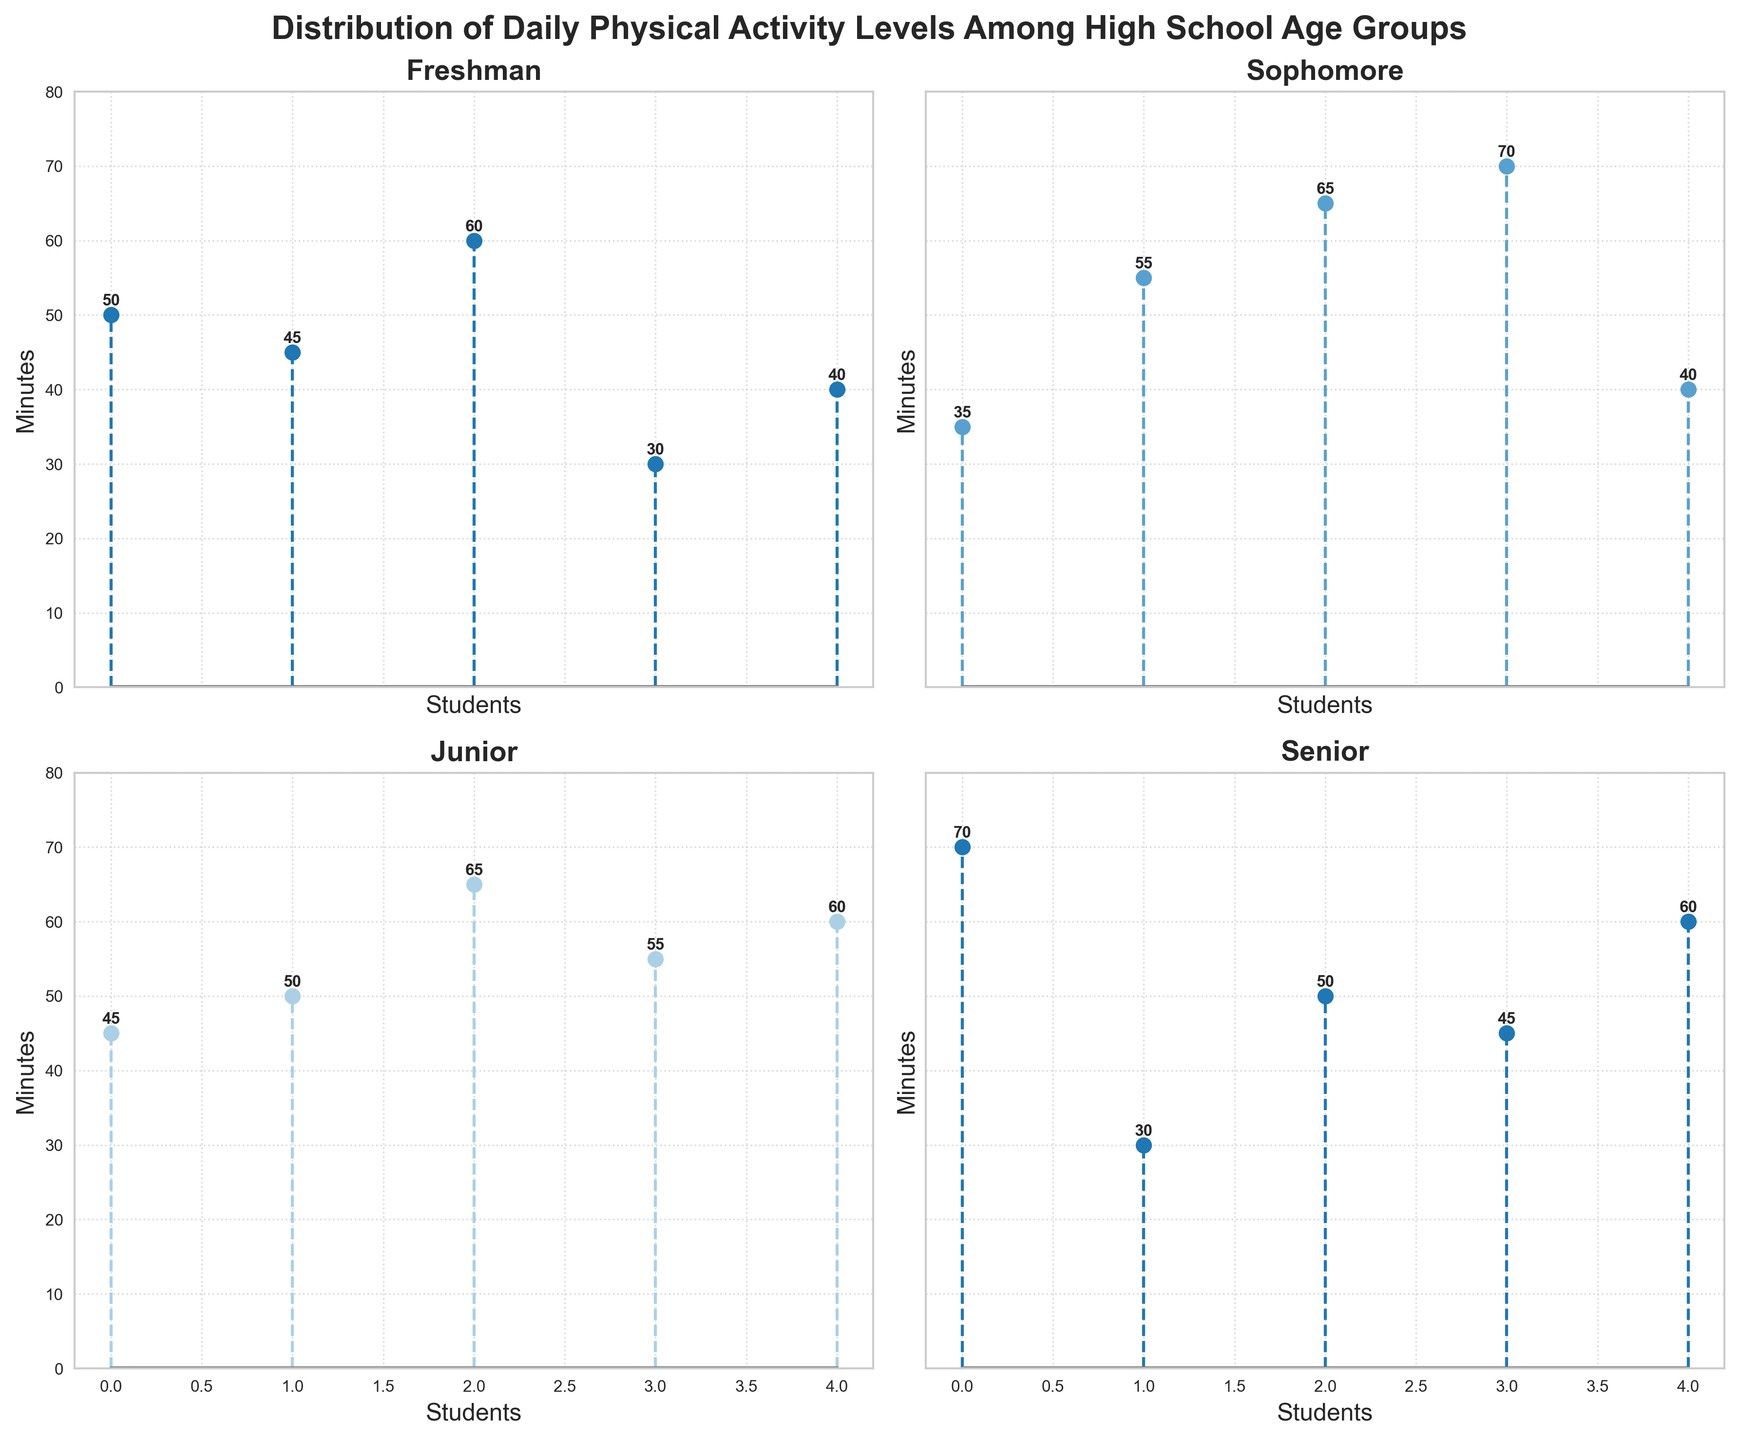What's the title of the figure? The title of the figure is displayed at the top in bold font. It provides an overview of what the figure represents.
Answer: Distribution of Daily Physical Activity Levels Among High School Age Groups How many students in the Sophomore category have more than 50 minutes of daily physical activity? Look at the subplot titled 'Sophomore' and count the number of data points that are above the 50-minute mark.
Answer: 3 Which age group has the highest individual daily physical activity level? Compare the maximum value of daily physical activity minutes for each age group from their respective subplots.
Answer: Senior What is the range of daily physical activity levels for Juniors? Identify the minimum and maximum values of daily physical activity minutes from the 'Junior' subplot, then calculate the difference between them.
Answer: 45 to 65 minutes What is the average daily physical activity level for Freshmen? Sum the daily physical activity minutes for all Freshman students and divide by the number of Freshman students. There are 5 students with values 50, 45, 60, 30, and 40. Their sum is 225 and the average is 225/5.
Answer: 45 minutes 